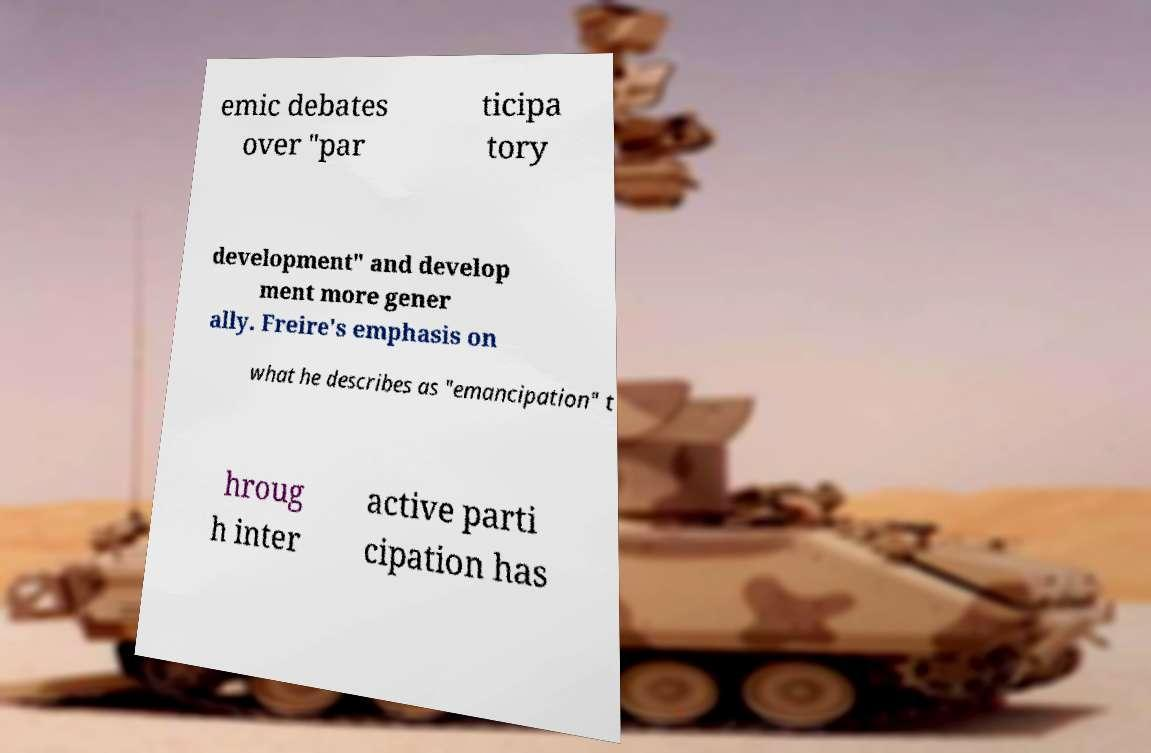Please identify and transcribe the text found in this image. emic debates over "par ticipa tory development" and develop ment more gener ally. Freire's emphasis on what he describes as "emancipation" t hroug h inter active parti cipation has 